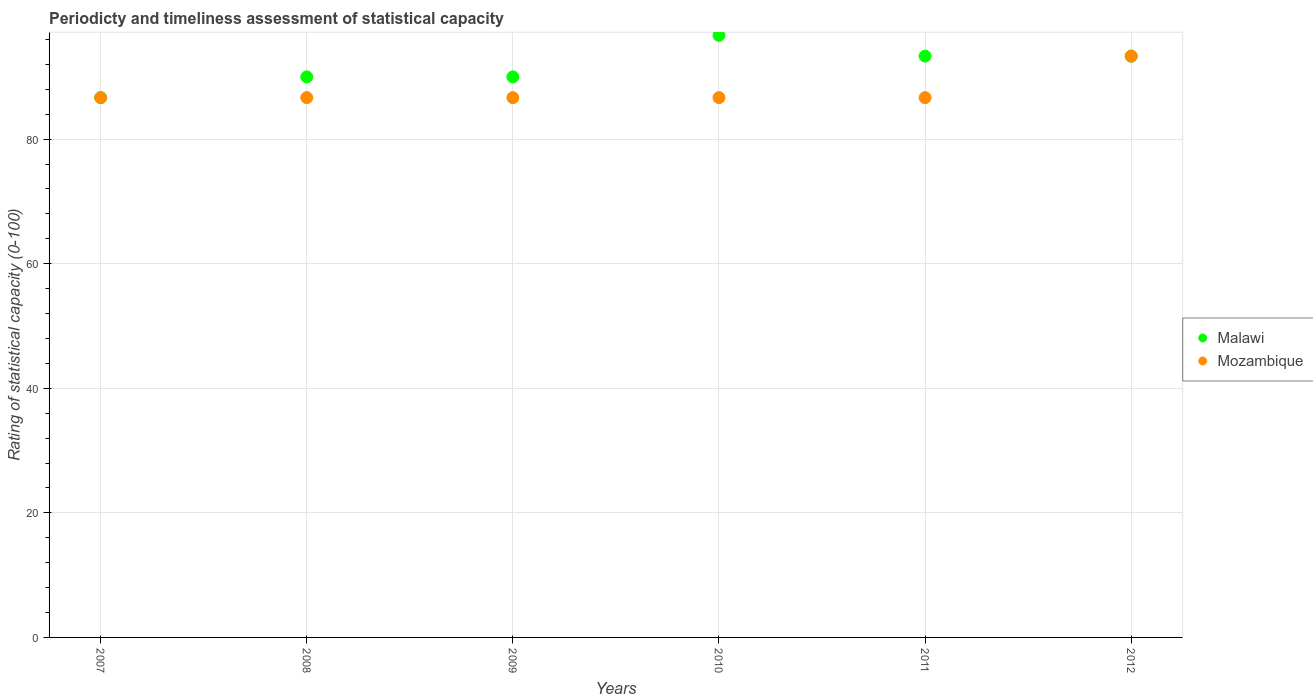How many different coloured dotlines are there?
Your answer should be very brief. 2. What is the rating of statistical capacity in Malawi in 2011?
Your answer should be very brief. 93.33. Across all years, what is the maximum rating of statistical capacity in Malawi?
Offer a terse response. 96.67. Across all years, what is the minimum rating of statistical capacity in Mozambique?
Your answer should be compact. 86.67. In which year was the rating of statistical capacity in Mozambique maximum?
Ensure brevity in your answer.  2012. In which year was the rating of statistical capacity in Mozambique minimum?
Provide a short and direct response. 2007. What is the total rating of statistical capacity in Mozambique in the graph?
Your response must be concise. 526.67. What is the difference between the rating of statistical capacity in Mozambique in 2008 and that in 2010?
Offer a terse response. 0. What is the difference between the rating of statistical capacity in Malawi in 2011 and the rating of statistical capacity in Mozambique in 2010?
Your answer should be very brief. 6.67. What is the average rating of statistical capacity in Malawi per year?
Provide a short and direct response. 91.67. In the year 2008, what is the difference between the rating of statistical capacity in Mozambique and rating of statistical capacity in Malawi?
Give a very brief answer. -3.33. In how many years, is the rating of statistical capacity in Malawi greater than 44?
Provide a succinct answer. 6. What is the ratio of the rating of statistical capacity in Mozambique in 2011 to that in 2012?
Offer a terse response. 0.93. Is the rating of statistical capacity in Malawi in 2007 less than that in 2009?
Keep it short and to the point. Yes. Is the difference between the rating of statistical capacity in Mozambique in 2007 and 2008 greater than the difference between the rating of statistical capacity in Malawi in 2007 and 2008?
Keep it short and to the point. Yes. What is the difference between the highest and the second highest rating of statistical capacity in Mozambique?
Keep it short and to the point. 6.67. Is the rating of statistical capacity in Mozambique strictly greater than the rating of statistical capacity in Malawi over the years?
Your answer should be very brief. No. How many dotlines are there?
Provide a succinct answer. 2. How many years are there in the graph?
Give a very brief answer. 6. What is the difference between two consecutive major ticks on the Y-axis?
Keep it short and to the point. 20. Are the values on the major ticks of Y-axis written in scientific E-notation?
Offer a terse response. No. Does the graph contain any zero values?
Make the answer very short. No. Does the graph contain grids?
Your answer should be compact. Yes. How many legend labels are there?
Provide a short and direct response. 2. How are the legend labels stacked?
Your response must be concise. Vertical. What is the title of the graph?
Provide a short and direct response. Periodicty and timeliness assessment of statistical capacity. What is the label or title of the Y-axis?
Provide a succinct answer. Rating of statistical capacity (0-100). What is the Rating of statistical capacity (0-100) of Malawi in 2007?
Offer a terse response. 86.67. What is the Rating of statistical capacity (0-100) of Mozambique in 2007?
Provide a short and direct response. 86.67. What is the Rating of statistical capacity (0-100) of Mozambique in 2008?
Keep it short and to the point. 86.67. What is the Rating of statistical capacity (0-100) in Malawi in 2009?
Offer a very short reply. 90. What is the Rating of statistical capacity (0-100) of Mozambique in 2009?
Make the answer very short. 86.67. What is the Rating of statistical capacity (0-100) in Malawi in 2010?
Provide a succinct answer. 96.67. What is the Rating of statistical capacity (0-100) in Mozambique in 2010?
Make the answer very short. 86.67. What is the Rating of statistical capacity (0-100) in Malawi in 2011?
Provide a short and direct response. 93.33. What is the Rating of statistical capacity (0-100) in Mozambique in 2011?
Your response must be concise. 86.67. What is the Rating of statistical capacity (0-100) in Malawi in 2012?
Offer a terse response. 93.33. What is the Rating of statistical capacity (0-100) in Mozambique in 2012?
Offer a very short reply. 93.33. Across all years, what is the maximum Rating of statistical capacity (0-100) in Malawi?
Offer a terse response. 96.67. Across all years, what is the maximum Rating of statistical capacity (0-100) in Mozambique?
Provide a succinct answer. 93.33. Across all years, what is the minimum Rating of statistical capacity (0-100) in Malawi?
Offer a terse response. 86.67. Across all years, what is the minimum Rating of statistical capacity (0-100) of Mozambique?
Your response must be concise. 86.67. What is the total Rating of statistical capacity (0-100) in Malawi in the graph?
Provide a short and direct response. 550. What is the total Rating of statistical capacity (0-100) of Mozambique in the graph?
Offer a very short reply. 526.67. What is the difference between the Rating of statistical capacity (0-100) of Mozambique in 2007 and that in 2008?
Make the answer very short. 0. What is the difference between the Rating of statistical capacity (0-100) in Mozambique in 2007 and that in 2010?
Offer a terse response. 0. What is the difference between the Rating of statistical capacity (0-100) of Malawi in 2007 and that in 2011?
Give a very brief answer. -6.67. What is the difference between the Rating of statistical capacity (0-100) in Malawi in 2007 and that in 2012?
Provide a succinct answer. -6.67. What is the difference between the Rating of statistical capacity (0-100) in Mozambique in 2007 and that in 2012?
Make the answer very short. -6.67. What is the difference between the Rating of statistical capacity (0-100) in Malawi in 2008 and that in 2009?
Ensure brevity in your answer.  0. What is the difference between the Rating of statistical capacity (0-100) of Mozambique in 2008 and that in 2009?
Offer a terse response. 0. What is the difference between the Rating of statistical capacity (0-100) in Malawi in 2008 and that in 2010?
Keep it short and to the point. -6.67. What is the difference between the Rating of statistical capacity (0-100) in Mozambique in 2008 and that in 2010?
Your answer should be very brief. 0. What is the difference between the Rating of statistical capacity (0-100) in Mozambique in 2008 and that in 2011?
Offer a very short reply. 0. What is the difference between the Rating of statistical capacity (0-100) of Malawi in 2008 and that in 2012?
Your answer should be compact. -3.33. What is the difference between the Rating of statistical capacity (0-100) in Mozambique in 2008 and that in 2012?
Make the answer very short. -6.67. What is the difference between the Rating of statistical capacity (0-100) of Malawi in 2009 and that in 2010?
Your answer should be very brief. -6.67. What is the difference between the Rating of statistical capacity (0-100) in Mozambique in 2009 and that in 2010?
Ensure brevity in your answer.  0. What is the difference between the Rating of statistical capacity (0-100) of Mozambique in 2009 and that in 2011?
Provide a succinct answer. 0. What is the difference between the Rating of statistical capacity (0-100) in Mozambique in 2009 and that in 2012?
Provide a short and direct response. -6.67. What is the difference between the Rating of statistical capacity (0-100) in Malawi in 2010 and that in 2012?
Offer a terse response. 3.33. What is the difference between the Rating of statistical capacity (0-100) of Mozambique in 2010 and that in 2012?
Ensure brevity in your answer.  -6.67. What is the difference between the Rating of statistical capacity (0-100) of Mozambique in 2011 and that in 2012?
Give a very brief answer. -6.67. What is the difference between the Rating of statistical capacity (0-100) in Malawi in 2007 and the Rating of statistical capacity (0-100) in Mozambique in 2008?
Offer a terse response. 0. What is the difference between the Rating of statistical capacity (0-100) in Malawi in 2007 and the Rating of statistical capacity (0-100) in Mozambique in 2011?
Offer a very short reply. 0. What is the difference between the Rating of statistical capacity (0-100) in Malawi in 2007 and the Rating of statistical capacity (0-100) in Mozambique in 2012?
Offer a very short reply. -6.67. What is the difference between the Rating of statistical capacity (0-100) in Malawi in 2008 and the Rating of statistical capacity (0-100) in Mozambique in 2011?
Provide a succinct answer. 3.33. What is the difference between the Rating of statistical capacity (0-100) in Malawi in 2009 and the Rating of statistical capacity (0-100) in Mozambique in 2010?
Give a very brief answer. 3.33. What is the difference between the Rating of statistical capacity (0-100) in Malawi in 2011 and the Rating of statistical capacity (0-100) in Mozambique in 2012?
Give a very brief answer. 0. What is the average Rating of statistical capacity (0-100) in Malawi per year?
Provide a succinct answer. 91.67. What is the average Rating of statistical capacity (0-100) in Mozambique per year?
Provide a succinct answer. 87.78. In the year 2007, what is the difference between the Rating of statistical capacity (0-100) in Malawi and Rating of statistical capacity (0-100) in Mozambique?
Keep it short and to the point. 0. In the year 2009, what is the difference between the Rating of statistical capacity (0-100) of Malawi and Rating of statistical capacity (0-100) of Mozambique?
Provide a short and direct response. 3.33. In the year 2010, what is the difference between the Rating of statistical capacity (0-100) in Malawi and Rating of statistical capacity (0-100) in Mozambique?
Provide a short and direct response. 10. What is the ratio of the Rating of statistical capacity (0-100) in Malawi in 2007 to that in 2010?
Give a very brief answer. 0.9. What is the ratio of the Rating of statistical capacity (0-100) of Mozambique in 2007 to that in 2011?
Give a very brief answer. 1. What is the ratio of the Rating of statistical capacity (0-100) in Mozambique in 2007 to that in 2012?
Make the answer very short. 0.93. What is the ratio of the Rating of statistical capacity (0-100) in Mozambique in 2008 to that in 2009?
Provide a succinct answer. 1. What is the ratio of the Rating of statistical capacity (0-100) in Malawi in 2008 to that in 2011?
Keep it short and to the point. 0.96. What is the ratio of the Rating of statistical capacity (0-100) of Malawi in 2009 to that in 2012?
Ensure brevity in your answer.  0.96. What is the ratio of the Rating of statistical capacity (0-100) in Malawi in 2010 to that in 2011?
Your response must be concise. 1.04. What is the ratio of the Rating of statistical capacity (0-100) of Mozambique in 2010 to that in 2011?
Provide a short and direct response. 1. What is the ratio of the Rating of statistical capacity (0-100) in Malawi in 2010 to that in 2012?
Your answer should be very brief. 1.04. What is the ratio of the Rating of statistical capacity (0-100) in Malawi in 2011 to that in 2012?
Provide a succinct answer. 1. What is the ratio of the Rating of statistical capacity (0-100) of Mozambique in 2011 to that in 2012?
Give a very brief answer. 0.93. What is the difference between the highest and the second highest Rating of statistical capacity (0-100) in Mozambique?
Your answer should be compact. 6.67. What is the difference between the highest and the lowest Rating of statistical capacity (0-100) in Malawi?
Provide a succinct answer. 10. 